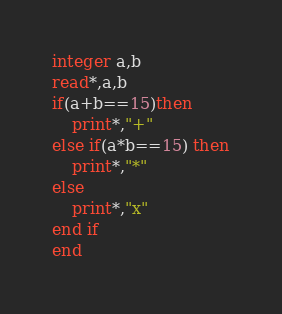Convert code to text. <code><loc_0><loc_0><loc_500><loc_500><_FORTRAN_>integer a,b
read*,a,b
if(a+b==15)then
	print*,"+"
else if(a*b==15) then
	print*,"*"
else
	print*,"x"
end if
end</code> 